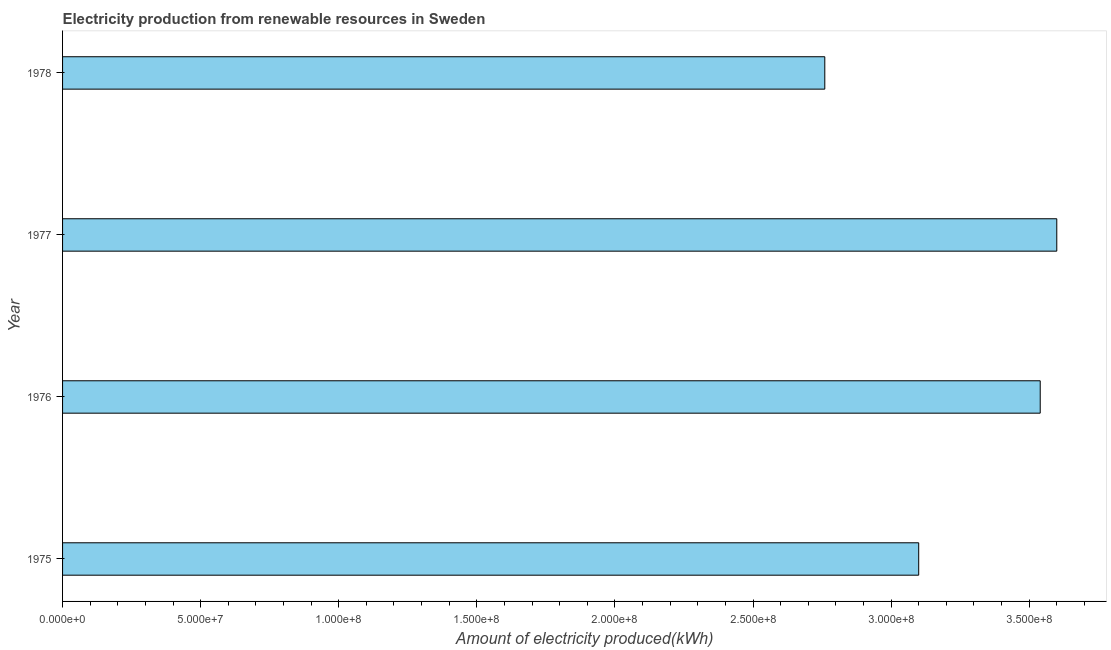Does the graph contain grids?
Your answer should be compact. No. What is the title of the graph?
Ensure brevity in your answer.  Electricity production from renewable resources in Sweden. What is the label or title of the X-axis?
Keep it short and to the point. Amount of electricity produced(kWh). What is the amount of electricity produced in 1976?
Ensure brevity in your answer.  3.54e+08. Across all years, what is the maximum amount of electricity produced?
Keep it short and to the point. 3.60e+08. Across all years, what is the minimum amount of electricity produced?
Offer a very short reply. 2.76e+08. In which year was the amount of electricity produced minimum?
Your answer should be compact. 1978. What is the sum of the amount of electricity produced?
Make the answer very short. 1.30e+09. What is the difference between the amount of electricity produced in 1975 and 1976?
Your answer should be very brief. -4.40e+07. What is the average amount of electricity produced per year?
Offer a terse response. 3.25e+08. What is the median amount of electricity produced?
Provide a succinct answer. 3.32e+08. In how many years, is the amount of electricity produced greater than 240000000 kWh?
Your answer should be very brief. 4. Do a majority of the years between 1977 and 1978 (inclusive) have amount of electricity produced greater than 240000000 kWh?
Give a very brief answer. Yes. What is the ratio of the amount of electricity produced in 1975 to that in 1976?
Your answer should be compact. 0.88. Is the amount of electricity produced in 1976 less than that in 1978?
Ensure brevity in your answer.  No. What is the difference between the highest and the second highest amount of electricity produced?
Provide a short and direct response. 6.00e+06. Is the sum of the amount of electricity produced in 1975 and 1977 greater than the maximum amount of electricity produced across all years?
Your answer should be very brief. Yes. What is the difference between the highest and the lowest amount of electricity produced?
Give a very brief answer. 8.40e+07. In how many years, is the amount of electricity produced greater than the average amount of electricity produced taken over all years?
Give a very brief answer. 2. How many years are there in the graph?
Make the answer very short. 4. What is the difference between two consecutive major ticks on the X-axis?
Offer a terse response. 5.00e+07. What is the Amount of electricity produced(kWh) in 1975?
Keep it short and to the point. 3.10e+08. What is the Amount of electricity produced(kWh) of 1976?
Ensure brevity in your answer.  3.54e+08. What is the Amount of electricity produced(kWh) of 1977?
Keep it short and to the point. 3.60e+08. What is the Amount of electricity produced(kWh) of 1978?
Offer a very short reply. 2.76e+08. What is the difference between the Amount of electricity produced(kWh) in 1975 and 1976?
Offer a terse response. -4.40e+07. What is the difference between the Amount of electricity produced(kWh) in 1975 and 1977?
Your response must be concise. -5.00e+07. What is the difference between the Amount of electricity produced(kWh) in 1975 and 1978?
Give a very brief answer. 3.40e+07. What is the difference between the Amount of electricity produced(kWh) in 1976 and 1977?
Give a very brief answer. -6.00e+06. What is the difference between the Amount of electricity produced(kWh) in 1976 and 1978?
Keep it short and to the point. 7.80e+07. What is the difference between the Amount of electricity produced(kWh) in 1977 and 1978?
Your answer should be very brief. 8.40e+07. What is the ratio of the Amount of electricity produced(kWh) in 1975 to that in 1976?
Give a very brief answer. 0.88. What is the ratio of the Amount of electricity produced(kWh) in 1975 to that in 1977?
Ensure brevity in your answer.  0.86. What is the ratio of the Amount of electricity produced(kWh) in 1975 to that in 1978?
Give a very brief answer. 1.12. What is the ratio of the Amount of electricity produced(kWh) in 1976 to that in 1977?
Your answer should be compact. 0.98. What is the ratio of the Amount of electricity produced(kWh) in 1976 to that in 1978?
Give a very brief answer. 1.28. What is the ratio of the Amount of electricity produced(kWh) in 1977 to that in 1978?
Your response must be concise. 1.3. 